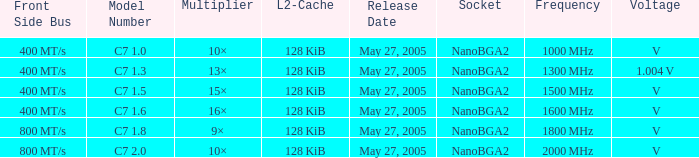What is the Release Date for Model Number c7 1.8? May 27, 2005. 